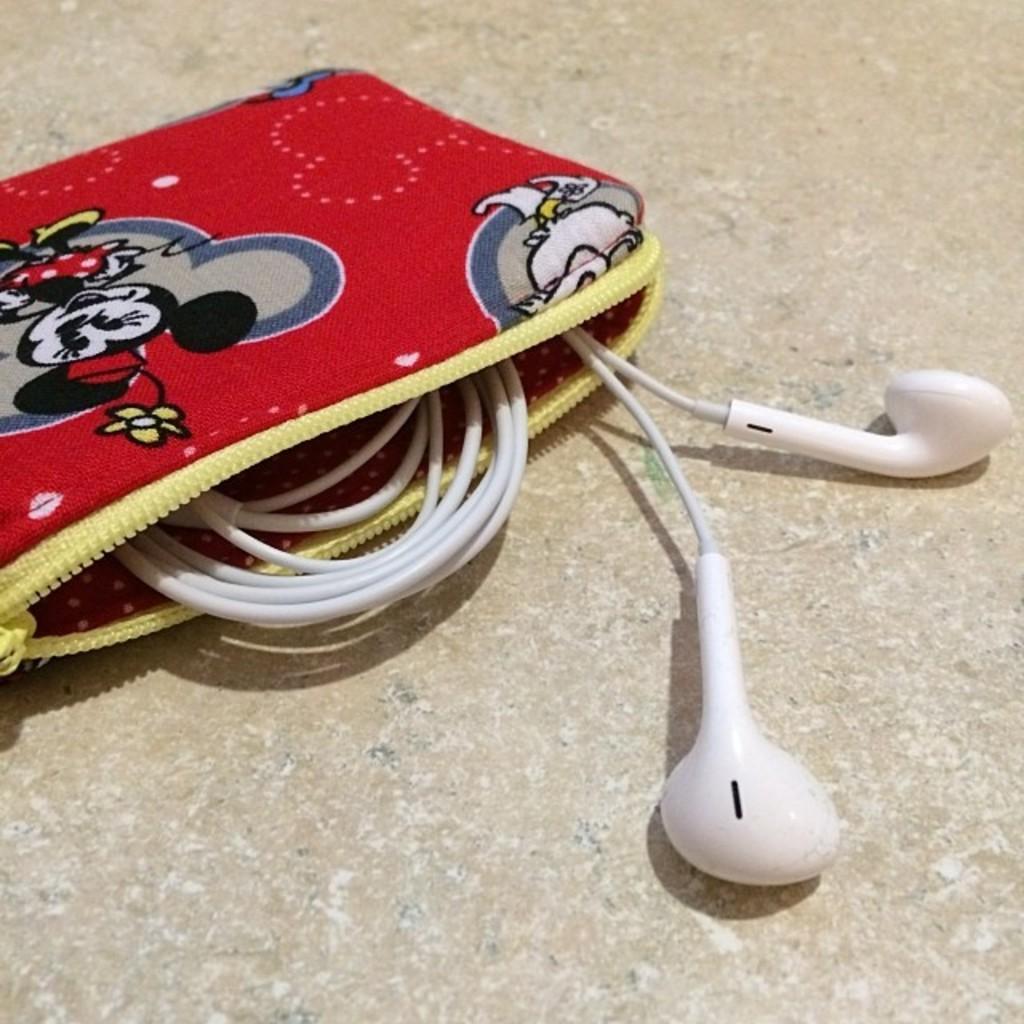Could you give a brief overview of what you see in this image? In this image we can see an earphone in the pouch. 